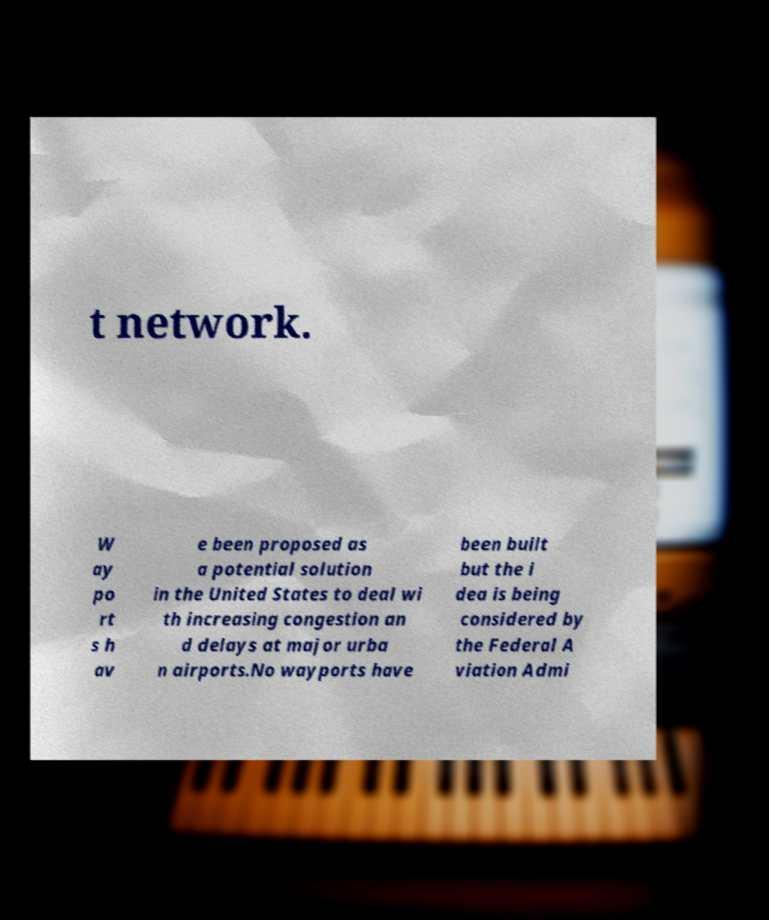There's text embedded in this image that I need extracted. Can you transcribe it verbatim? t network. W ay po rt s h av e been proposed as a potential solution in the United States to deal wi th increasing congestion an d delays at major urba n airports.No wayports have been built but the i dea is being considered by the Federal A viation Admi 